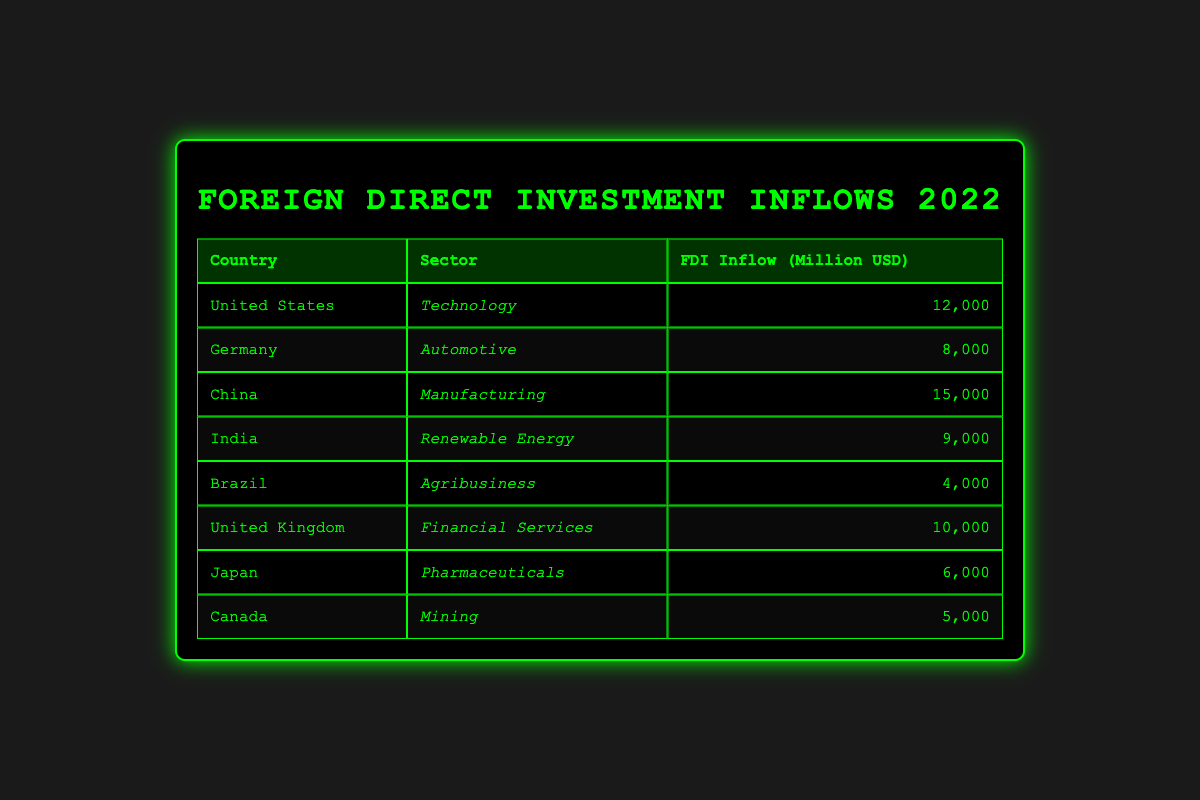What was the FDI inflow from China in 2022? The table directly lists the details for China, including its FDI inflow amount. According to the table, China's FDI inflow in 2022 was 15,000 million USD.
Answer: 15,000 million USD Which country received the highest FDI inflow in 2022? By comparing the FDI inflow values across all countries listed in the table, it's clear that China, with an inflow of 15,000 million USD, received the highest amount of foreign direct investment in 2022.
Answer: China What is the total FDI inflow for the sectors of Technology and Financial Services combined in 2022? To find this total, we add the FDI inflows of the Technology sector (12,000 million USD from the United States) and the Financial Services sector (10,000 million USD from the United Kingdom). Thus, the total inflow is 12,000 + 10,000 = 22,000 million USD.
Answer: 22,000 million USD Is the FDI inflow for India in Renewable Energy greater than that of Japan in Pharmaceuticals? The table shows that India's FDI inflow was 9,000 million USD while Japan's was 6,000 million USD. Since 9,000 is greater than 6,000, the statement is true.
Answer: Yes What percentage of the total FDI inflows from the table corresponds to the inflow from Brazil in Agribusiness? First, we find the total FDI inflows by adding all the individual inflows: 12,000 + 8,000 + 15,000 + 9,000 + 4,000 + 10,000 + 6,000 + 5,000 = 69,000 million USD. Then, we calculate the inflow from Brazil, which was 4,000 million USD. The percentage is then calculated as (4,000 / 69,000) * 100 ≈ 5.80%.
Answer: Approximately 5.80% Which sector had the least FDI inflow in 2022? By examining each row in the table, it is evident that the Agribusiness sector in Brazil, with an inflow of 4,000 million USD, had the lowest FDI inflow in 2022 compared to other sectors.
Answer: Agribusiness 